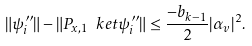Convert formula to latex. <formula><loc_0><loc_0><loc_500><loc_500>\| \psi ^ { \prime \prime } _ { i } \| - \| P _ { x , 1 } \ k e t { \psi ^ { \prime \prime } _ { i } } \| \leq \frac { - b _ { k - 1 } } { 2 } | \alpha _ { v } | ^ { 2 } .</formula> 